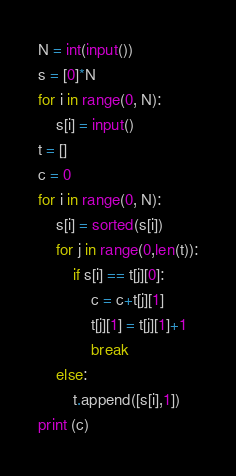Convert code to text. <code><loc_0><loc_0><loc_500><loc_500><_Python_>N = int(input())
s = [0]*N
for i in range(0, N):
    s[i] = input()
t = []
c = 0
for i in range(0, N):
    s[i] = sorted(s[i])
    for j in range(0,len(t)):
        if s[i] == t[j][0]:
            c = c+t[j][1]
            t[j][1] = t[j][1]+1
            break
    else:
        t.append([s[i],1])
print (c)</code> 